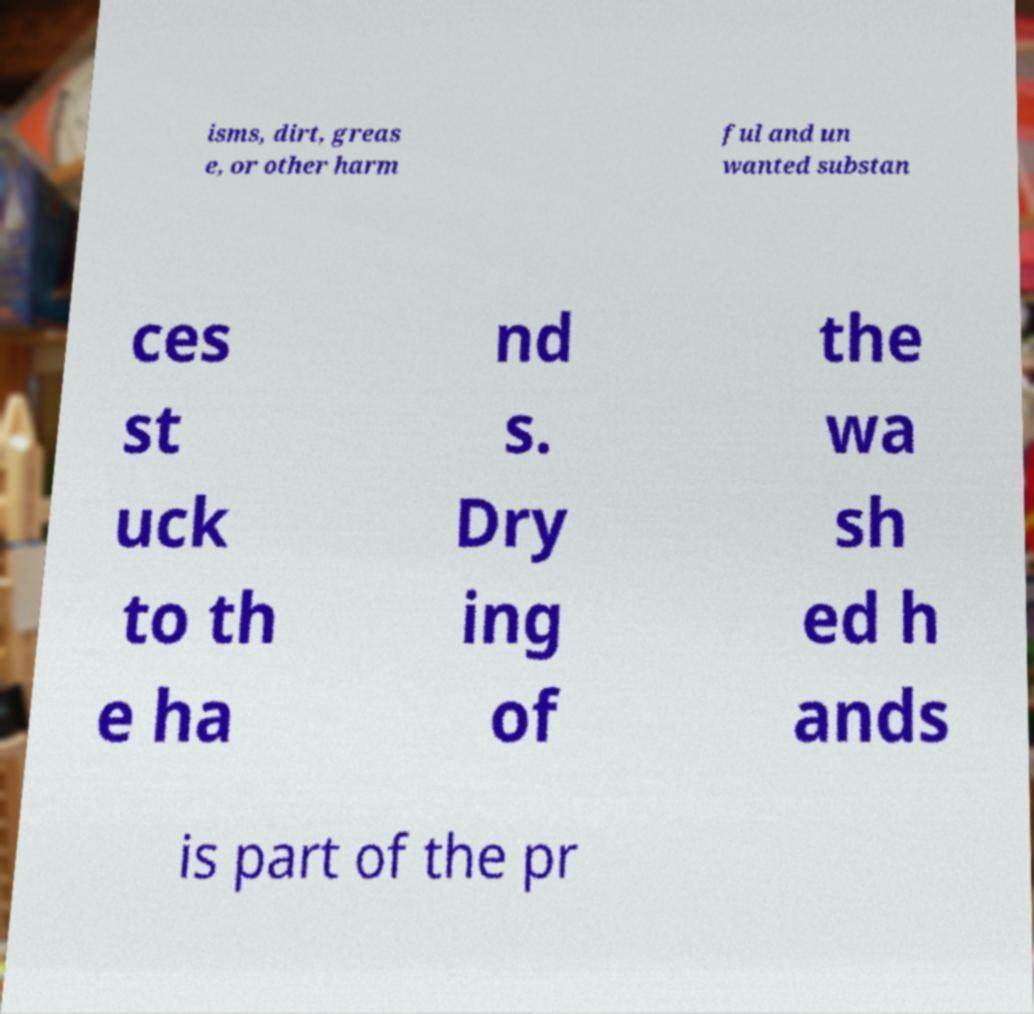Can you accurately transcribe the text from the provided image for me? isms, dirt, greas e, or other harm ful and un wanted substan ces st uck to th e ha nd s. Dry ing of the wa sh ed h ands is part of the pr 